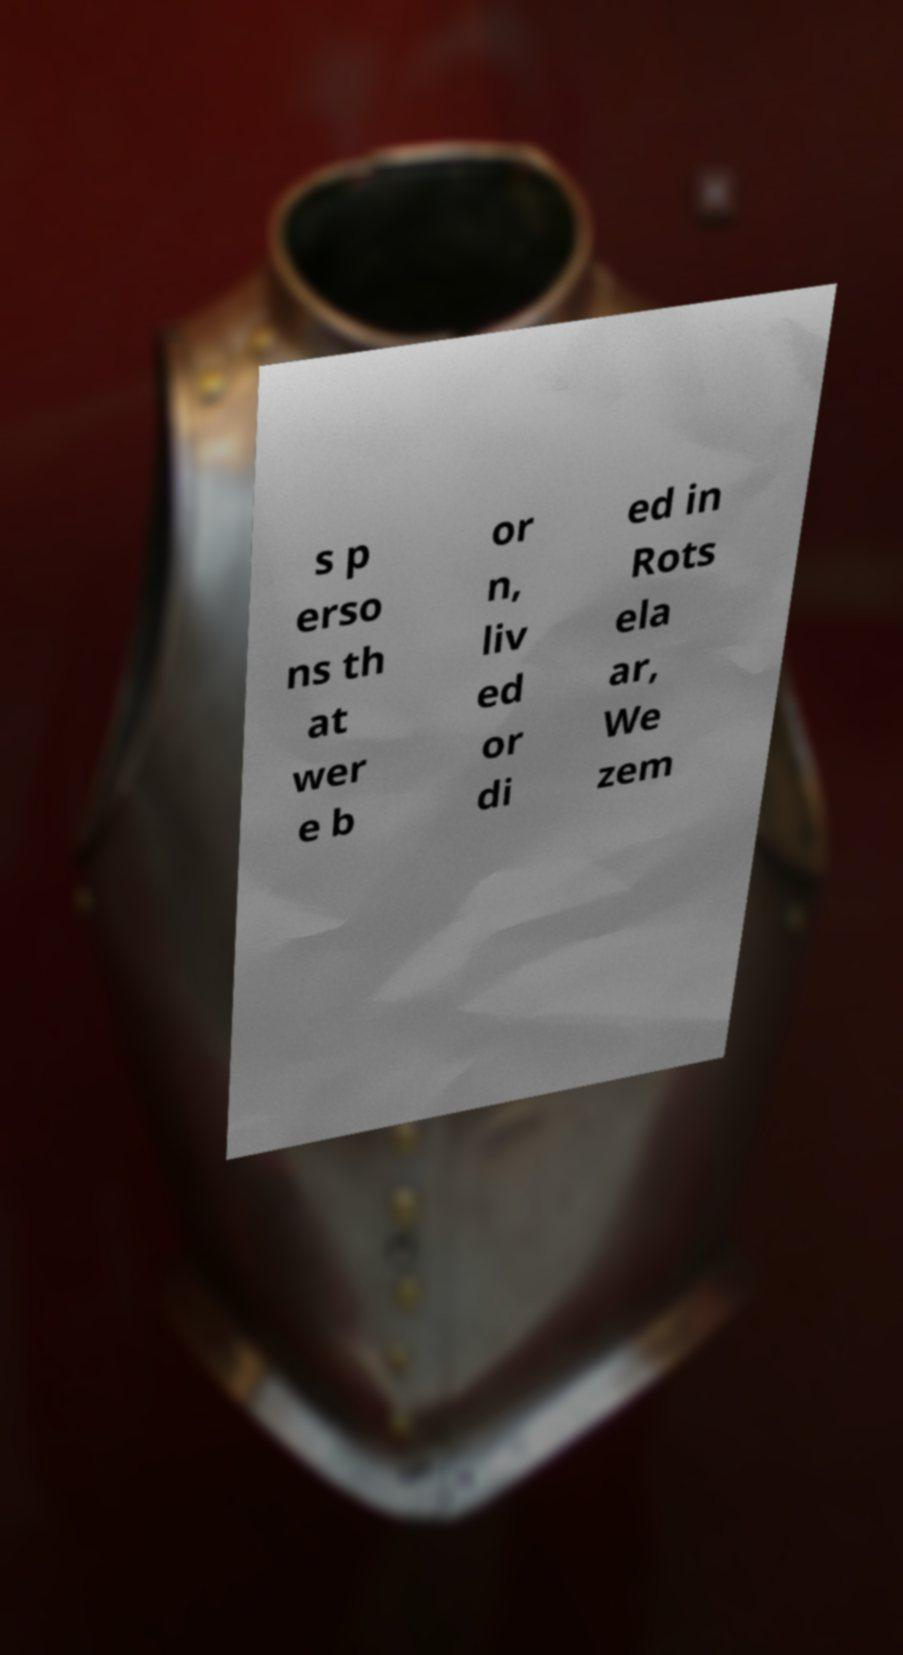Can you accurately transcribe the text from the provided image for me? s p erso ns th at wer e b or n, liv ed or di ed in Rots ela ar, We zem 